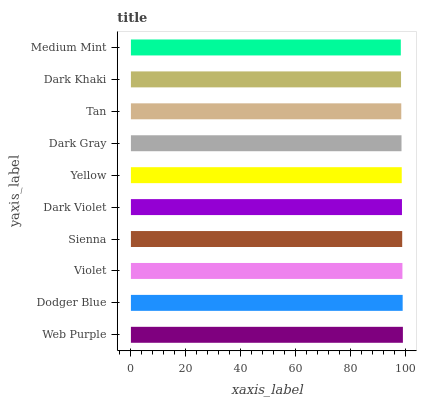Is Medium Mint the minimum?
Answer yes or no. Yes. Is Web Purple the maximum?
Answer yes or no. Yes. Is Dodger Blue the minimum?
Answer yes or no. No. Is Dodger Blue the maximum?
Answer yes or no. No. Is Web Purple greater than Dodger Blue?
Answer yes or no. Yes. Is Dodger Blue less than Web Purple?
Answer yes or no. Yes. Is Dodger Blue greater than Web Purple?
Answer yes or no. No. Is Web Purple less than Dodger Blue?
Answer yes or no. No. Is Dark Violet the high median?
Answer yes or no. Yes. Is Yellow the low median?
Answer yes or no. Yes. Is Dark Khaki the high median?
Answer yes or no. No. Is Medium Mint the low median?
Answer yes or no. No. 